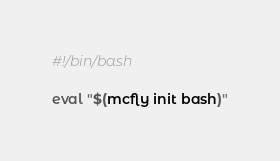<code> <loc_0><loc_0><loc_500><loc_500><_Bash_>#!/bin/bash

eval "$(mcfly init bash)"
</code> 